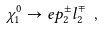<formula> <loc_0><loc_0><loc_500><loc_500>\chi _ { 1 } ^ { 0 } \to \sl e p _ { 2 } ^ { \pm } l _ { 2 } ^ { \mp } \ ,</formula> 